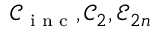<formula> <loc_0><loc_0><loc_500><loc_500>\mathcal { C } _ { i n c } , \mathcal { C } _ { 2 } , \mathcal { E } _ { 2 n }</formula> 